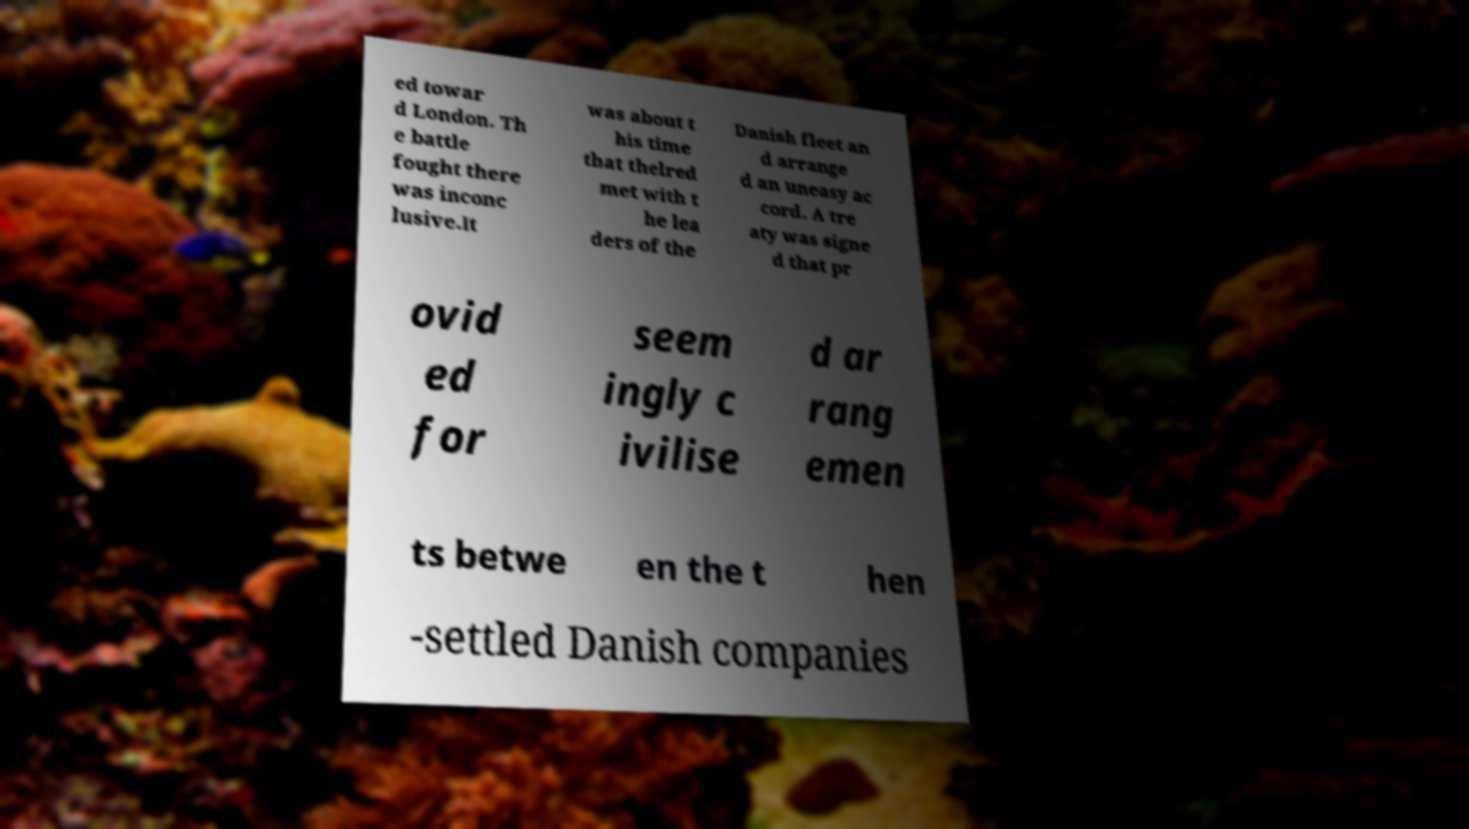Please identify and transcribe the text found in this image. ed towar d London. Th e battle fought there was inconc lusive.It was about t his time that thelred met with t he lea ders of the Danish fleet an d arrange d an uneasy ac cord. A tre aty was signe d that pr ovid ed for seem ingly c ivilise d ar rang emen ts betwe en the t hen -settled Danish companies 